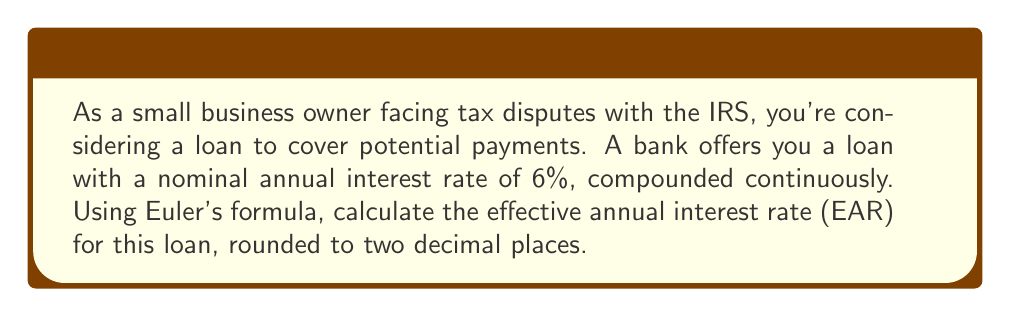Provide a solution to this math problem. To solve this problem, we'll use Euler's formula in the context of continuous compound interest. The formula for the effective annual interest rate (EAR) with continuous compounding is:

$$ EAR = e^r - 1 $$

Where $e$ is Euler's number (approximately 2.71828) and $r$ is the nominal annual interest rate expressed as a decimal.

Given:
- Nominal annual interest rate = 6% = 0.06

Steps:
1. Apply Euler's formula:
   $$ EAR = e^{0.06} - 1 $$

2. Calculate $e^{0.06}$ using a calculator or computer:
   $$ e^{0.06} \approx 1.0618365788 $$

3. Subtract 1 from the result:
   $$ EAR = 1.0618365788 - 1 = 0.0618365788 $$

4. Convert to a percentage and round to two decimal places:
   $$ EAR \approx 6.18\% $$

This means that the effective annual interest rate for the loan with 6% nominal annual interest, compounded continuously, is approximately 6.18%.
Answer: 6.18% 